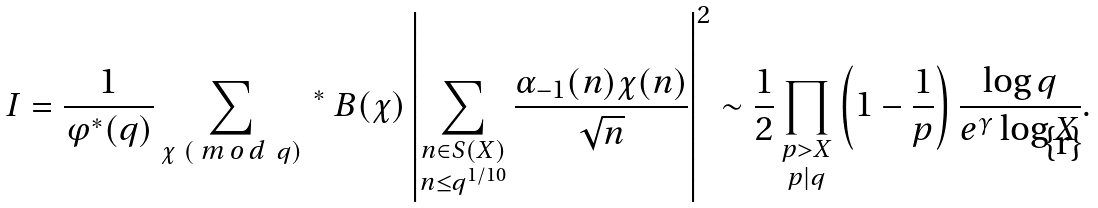Convert formula to latex. <formula><loc_0><loc_0><loc_500><loc_500>I = \frac { 1 } { \varphi ^ { * } ( q ) } \sum _ { \chi \ ( \emph { m o d } \ q ) } { \, } ^ { * } \ B ( \chi ) \left | \sum _ { \substack { n \in S ( X ) \\ n \leq q ^ { 1 / 1 0 } } } \frac { \alpha _ { - 1 } ( n ) \chi ( n ) } { \sqrt { n } } \right | ^ { 2 } \sim \frac { 1 } { 2 } \prod _ { \substack { p > X \\ p | q } } \left ( 1 - \frac { 1 } { p } \right ) \frac { \log q } { e ^ { \gamma } \log X } .</formula> 